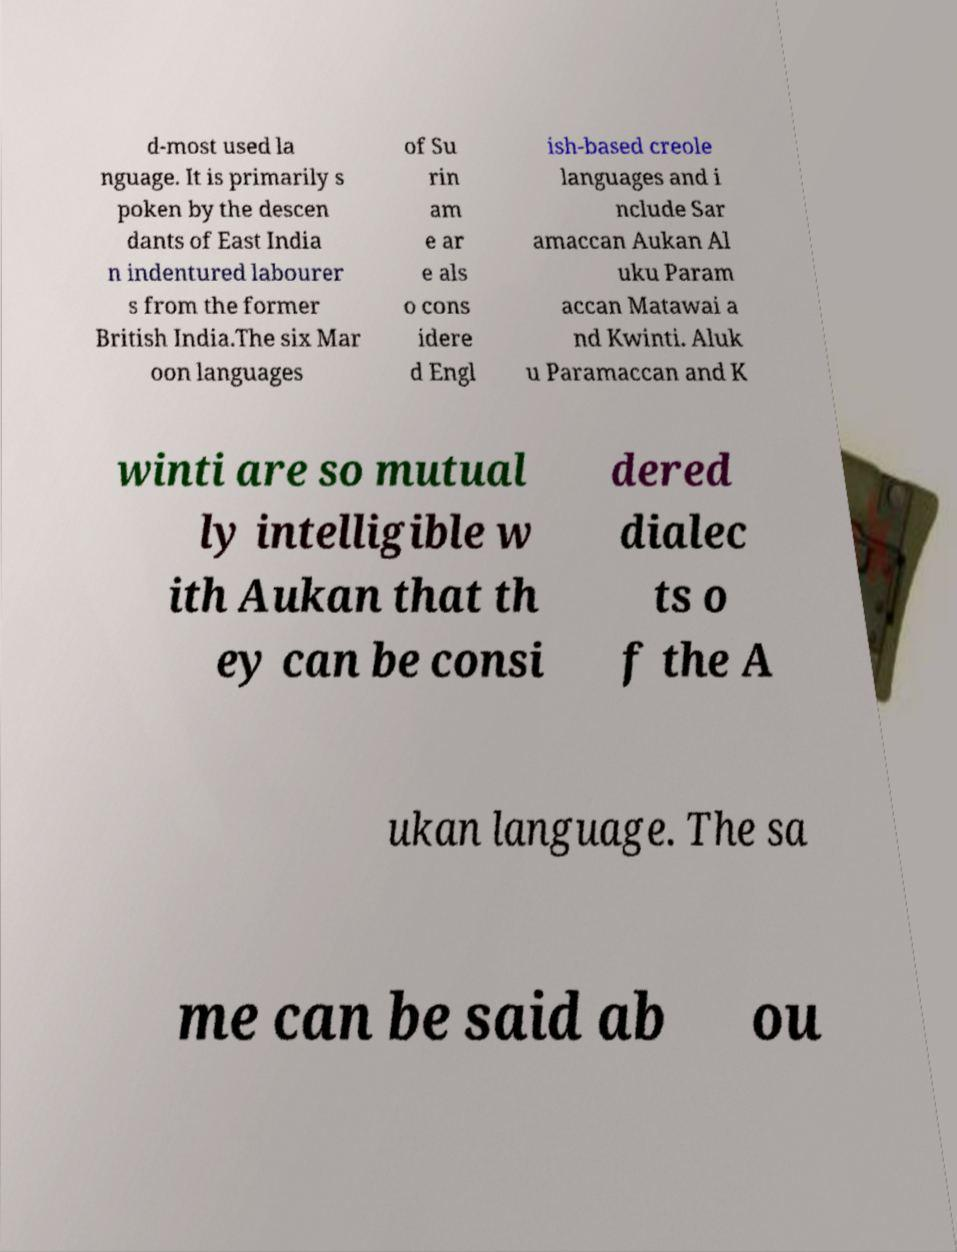Could you extract and type out the text from this image? d-most used la nguage. It is primarily s poken by the descen dants of East India n indentured labourer s from the former British India.The six Mar oon languages of Su rin am e ar e als o cons idere d Engl ish-based creole languages and i nclude Sar amaccan Aukan Al uku Param accan Matawai a nd Kwinti. Aluk u Paramaccan and K winti are so mutual ly intelligible w ith Aukan that th ey can be consi dered dialec ts o f the A ukan language. The sa me can be said ab ou 